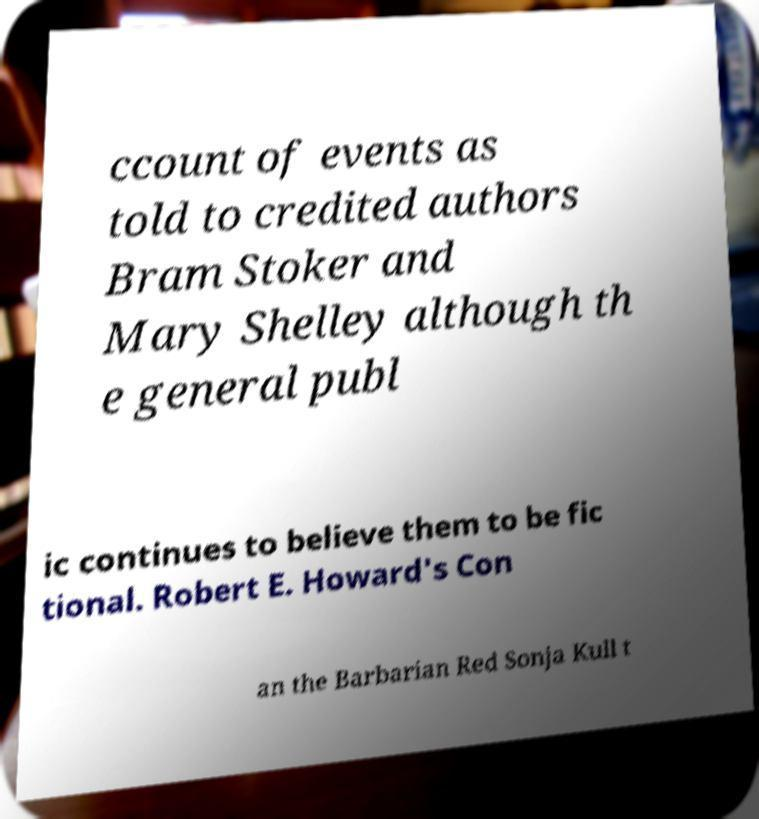Could you assist in decoding the text presented in this image and type it out clearly? ccount of events as told to credited authors Bram Stoker and Mary Shelley although th e general publ ic continues to believe them to be fic tional. Robert E. Howard's Con an the Barbarian Red Sonja Kull t 